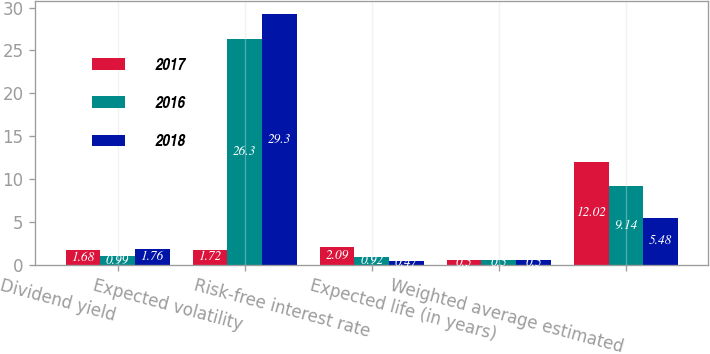Convert chart to OTSL. <chart><loc_0><loc_0><loc_500><loc_500><stacked_bar_chart><ecel><fcel>Dividend yield<fcel>Expected volatility<fcel>Risk-free interest rate<fcel>Expected life (in years)<fcel>Weighted average estimated<nl><fcel>2017<fcel>1.68<fcel>1.72<fcel>2.09<fcel>0.5<fcel>12.02<nl><fcel>2016<fcel>0.99<fcel>26.3<fcel>0.92<fcel>0.5<fcel>9.14<nl><fcel>2018<fcel>1.76<fcel>29.3<fcel>0.47<fcel>0.5<fcel>5.48<nl></chart> 